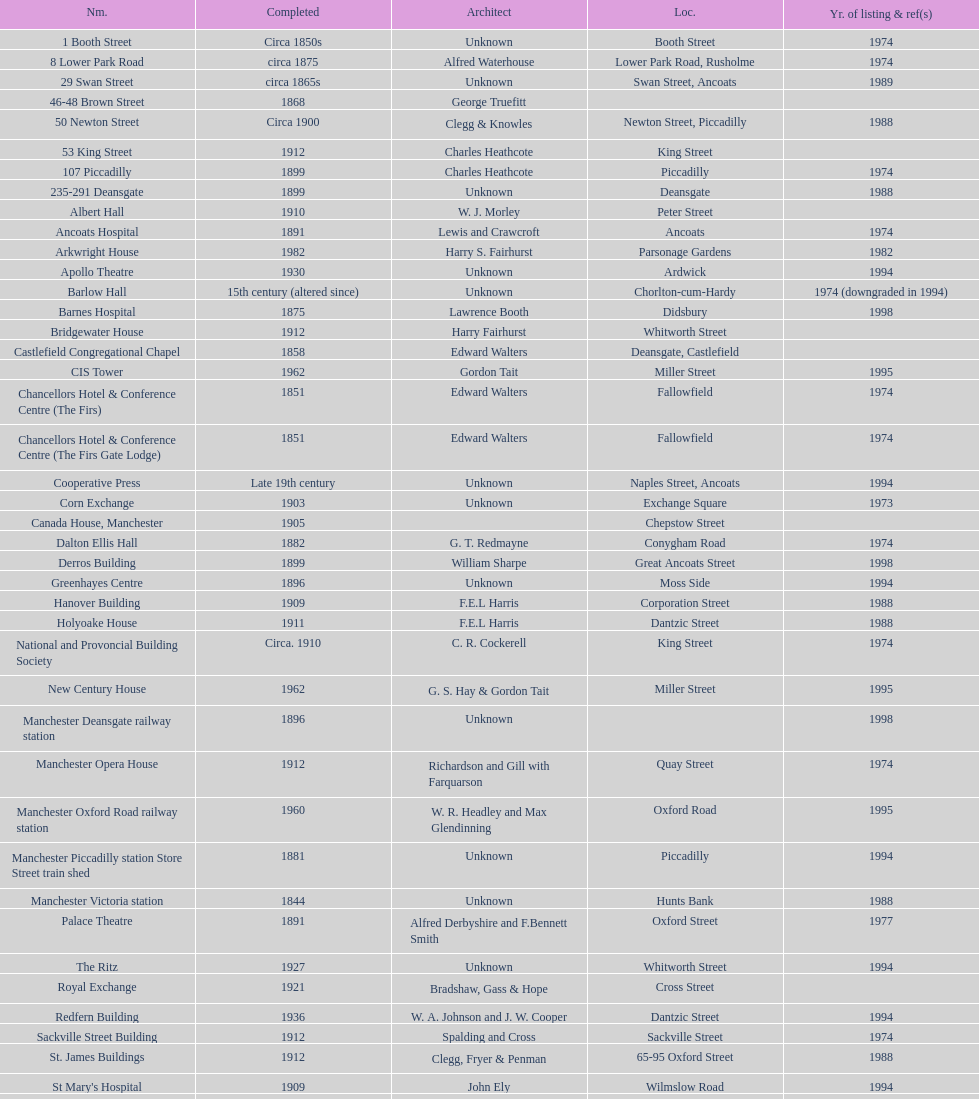Which year has the most buildings listed? 1974. 